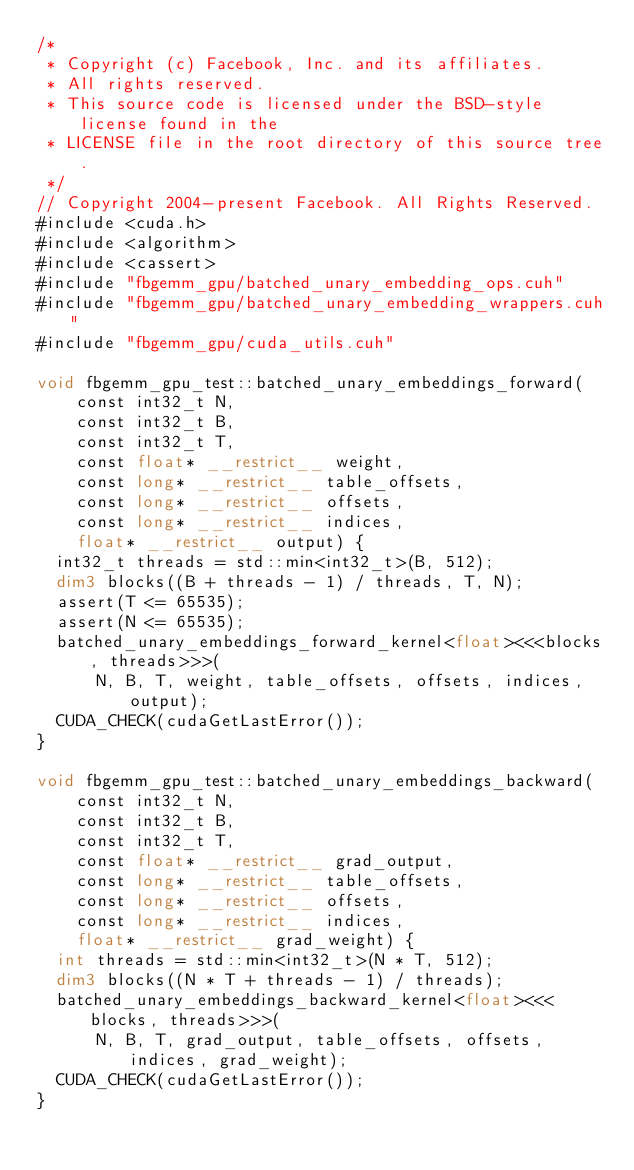Convert code to text. <code><loc_0><loc_0><loc_500><loc_500><_Cuda_>/*
 * Copyright (c) Facebook, Inc. and its affiliates.
 * All rights reserved.
 * This source code is licensed under the BSD-style license found in the
 * LICENSE file in the root directory of this source tree.
 */
// Copyright 2004-present Facebook. All Rights Reserved.
#include <cuda.h>
#include <algorithm>
#include <cassert>
#include "fbgemm_gpu/batched_unary_embedding_ops.cuh"
#include "fbgemm_gpu/batched_unary_embedding_wrappers.cuh"
#include "fbgemm_gpu/cuda_utils.cuh"

void fbgemm_gpu_test::batched_unary_embeddings_forward(
    const int32_t N,
    const int32_t B,
    const int32_t T,
    const float* __restrict__ weight,
    const long* __restrict__ table_offsets,
    const long* __restrict__ offsets,
    const long* __restrict__ indices,
    float* __restrict__ output) {
  int32_t threads = std::min<int32_t>(B, 512);
  dim3 blocks((B + threads - 1) / threads, T, N);
  assert(T <= 65535);
  assert(N <= 65535);
  batched_unary_embeddings_forward_kernel<float><<<blocks, threads>>>(
      N, B, T, weight, table_offsets, offsets, indices, output);
  CUDA_CHECK(cudaGetLastError());
}

void fbgemm_gpu_test::batched_unary_embeddings_backward(
    const int32_t N,
    const int32_t B,
    const int32_t T,
    const float* __restrict__ grad_output,
    const long* __restrict__ table_offsets,
    const long* __restrict__ offsets,
    const long* __restrict__ indices,
    float* __restrict__ grad_weight) {
  int threads = std::min<int32_t>(N * T, 512);
  dim3 blocks((N * T + threads - 1) / threads);
  batched_unary_embeddings_backward_kernel<float><<<blocks, threads>>>(
      N, B, T, grad_output, table_offsets, offsets, indices, grad_weight);
  CUDA_CHECK(cudaGetLastError());
}
</code> 